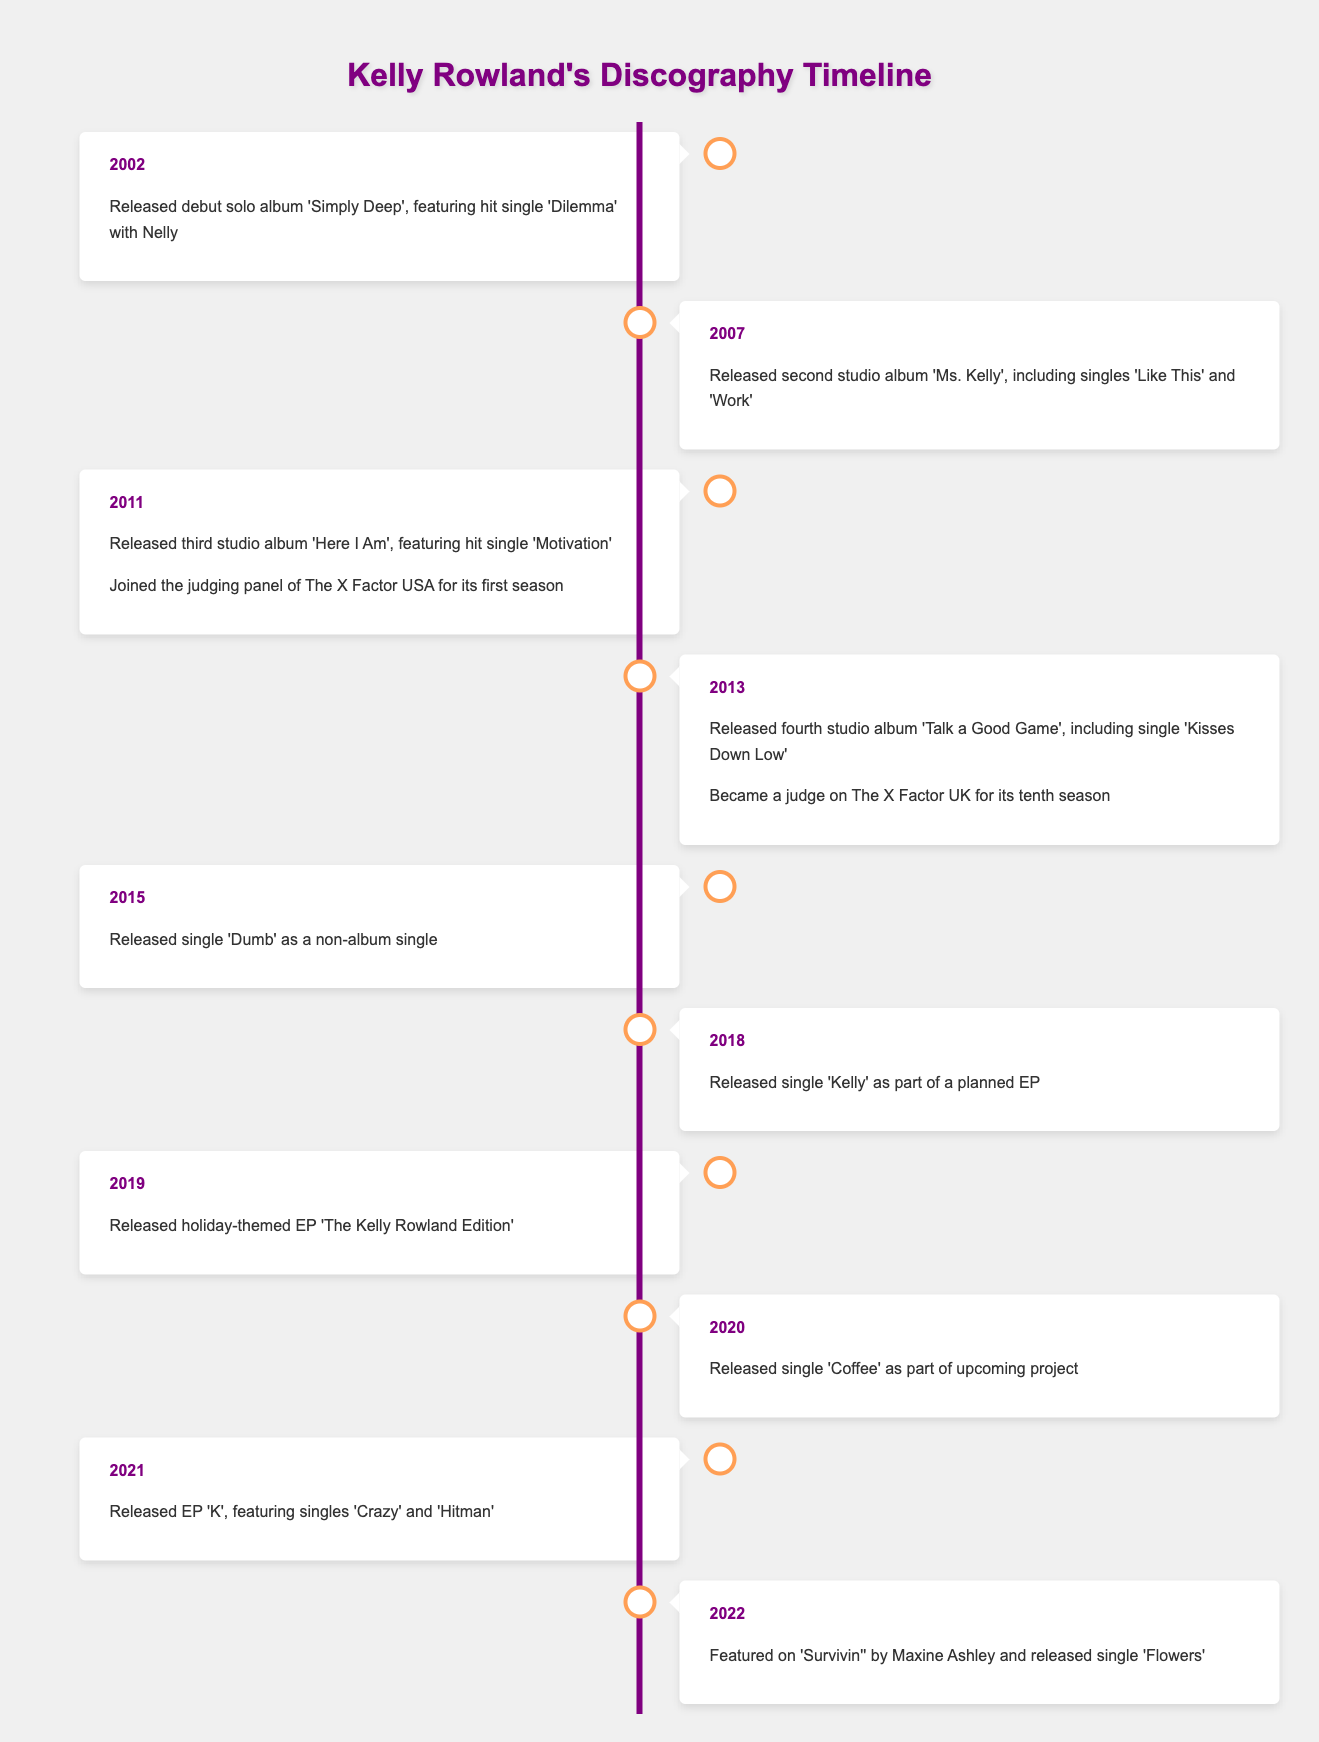What year did Kelly Rowland release her debut solo album? According to the timeline, Kelly Rowland released her debut solo album 'Simply Deep' in the year 2002.
Answer: 2002 How many studio albums did Kelly Rowland release between 2002 and 2013? The timeline shows that Kelly Rowland released four studio albums from 2002 to 2013: 'Simply Deep' (2002), 'Ms. Kelly' (2007), 'Here I Am' (2011), and 'Talk a Good Game' (2013).
Answer: 4 Was Kelly Rowland a judge on The X Factor USA? Yes, the timeline indicates that she joined the judging panel of The X Factor USA for its first season in 2011.
Answer: Yes In what year did Kelly Rowland release a holiday-themed EP? Based on the timeline, she released the holiday-themed EP 'The Kelly Rowland Edition' in 2019.
Answer: 2019 What was the difference in years between her second and third studio albums? Her second album 'Ms. Kelly' was released in 2007, and her third album 'Here I Am' was released in 2011. The difference is 2011 - 2007 = 4 years.
Answer: 4 years Which single features Nelly? The timeline specifically mentions that the hit single 'Dilemma' featuring Nelly is from her debut album 'Simply Deep' released in 2002.
Answer: Dilemma What is the most recent event mentioned in the timeline? The last event in the timeline is from 2022, where she featured on 'Survivin'' by Maxine Ashley and released a single titled 'Flowers'.
Answer: 2022 Did Kelly Rowland release any singles in 2015? Yes, she released the single 'Dumb' as a non-album single in 2015.
Answer: Yes What was the title of the EP released by Kelly Rowland in 2021? In 2021, she released an EP titled 'K', which featured singles 'Crazy' and 'Hitman'.
Answer: K 